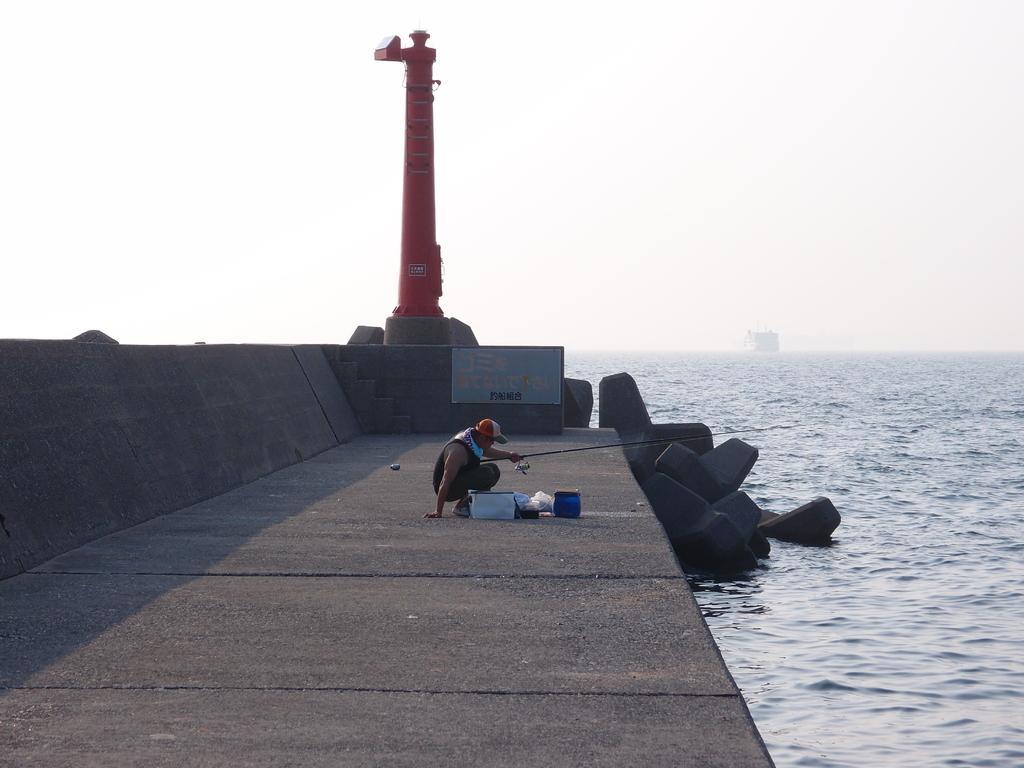Describe this image in one or two sentences. There is one person is wearing a cap and holding a fish rod. In front of him there is an ocean is present. There is a pole at the top of this image and there is a sky in the background. 